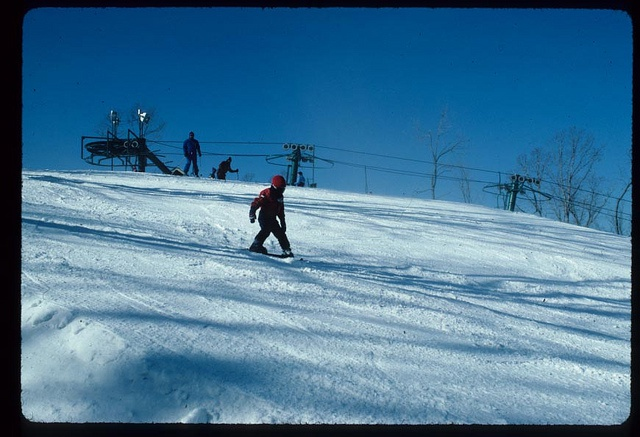Describe the objects in this image and their specific colors. I can see people in black, maroon, lightgray, and darkgray tones, people in black, navy, teal, and blue tones, people in black, navy, darkblue, and teal tones, people in black, darkblue, blue, and teal tones, and snowboard in black, blue, and gray tones in this image. 